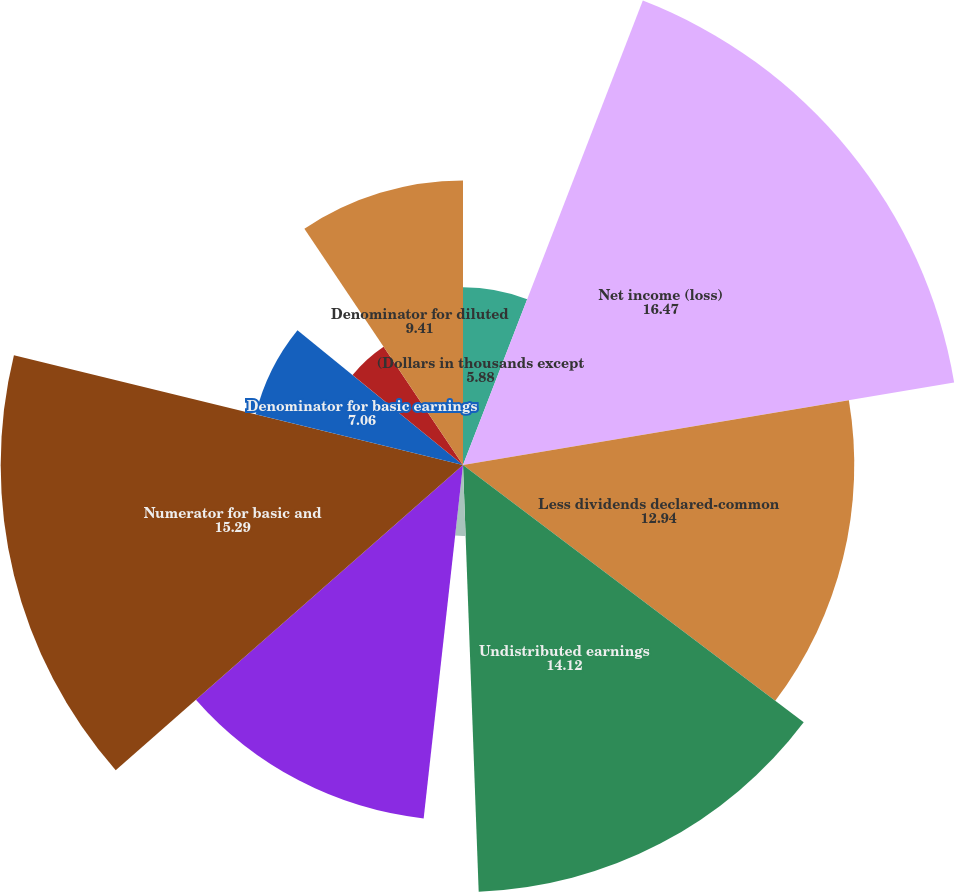Convert chart to OTSL. <chart><loc_0><loc_0><loc_500><loc_500><pie_chart><fcel>(Dollars in thousands except<fcel>Net income (loss)<fcel>Less dividends declared-common<fcel>Undistributed earnings<fcel>Percentage allocated to common<fcel>Add dividends declared-common<fcel>Numerator for basic and<fcel>Denominator for basic earnings<fcel>Options<fcel>Denominator for diluted<nl><fcel>5.88%<fcel>16.47%<fcel>12.94%<fcel>14.12%<fcel>2.35%<fcel>11.76%<fcel>15.29%<fcel>7.06%<fcel>4.71%<fcel>9.41%<nl></chart> 